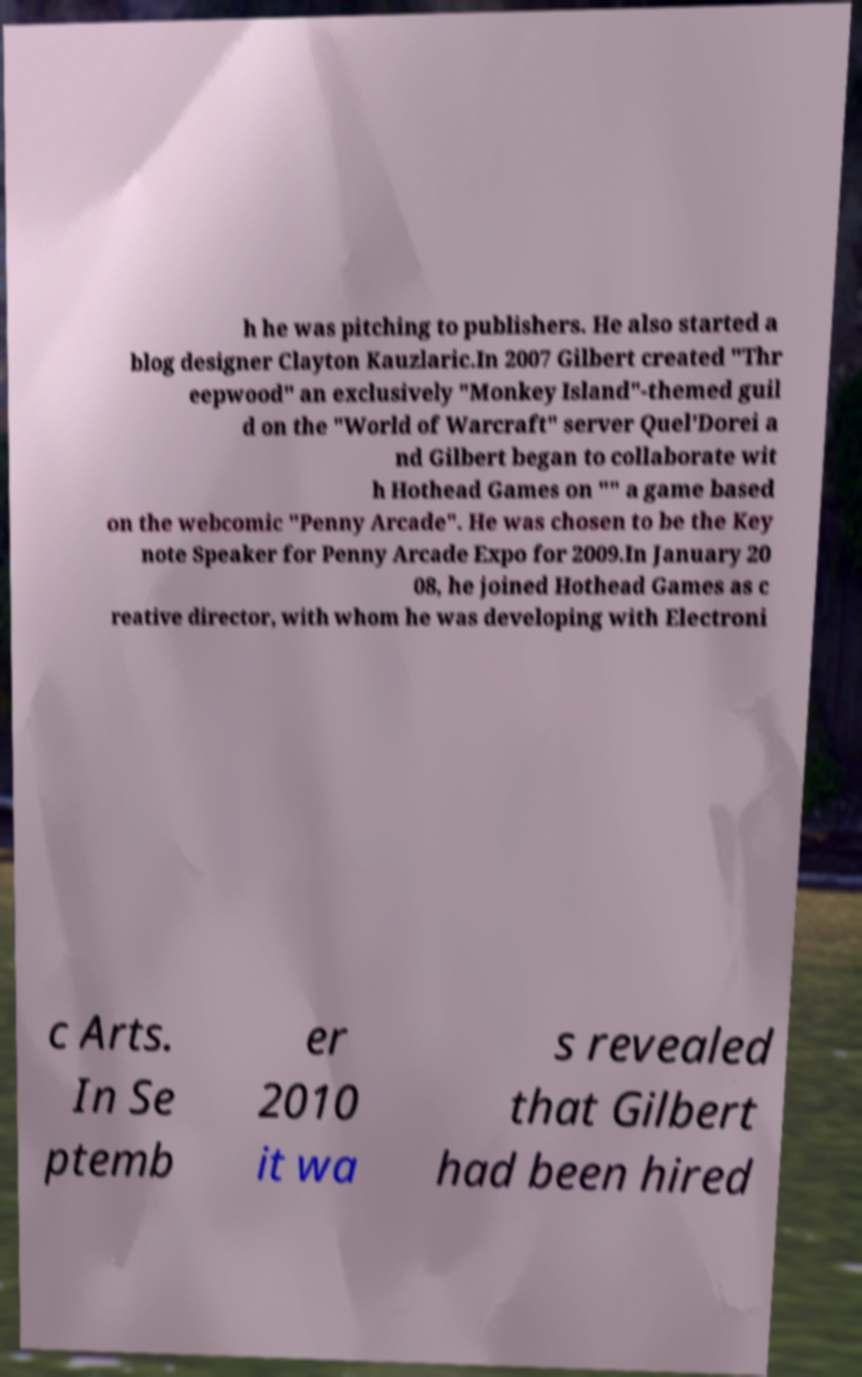There's text embedded in this image that I need extracted. Can you transcribe it verbatim? h he was pitching to publishers. He also started a blog designer Clayton Kauzlaric.In 2007 Gilbert created "Thr eepwood" an exclusively "Monkey Island"-themed guil d on the "World of Warcraft" server Quel'Dorei a nd Gilbert began to collaborate wit h Hothead Games on "" a game based on the webcomic "Penny Arcade". He was chosen to be the Key note Speaker for Penny Arcade Expo for 2009.In January 20 08, he joined Hothead Games as c reative director, with whom he was developing with Electroni c Arts. In Se ptemb er 2010 it wa s revealed that Gilbert had been hired 